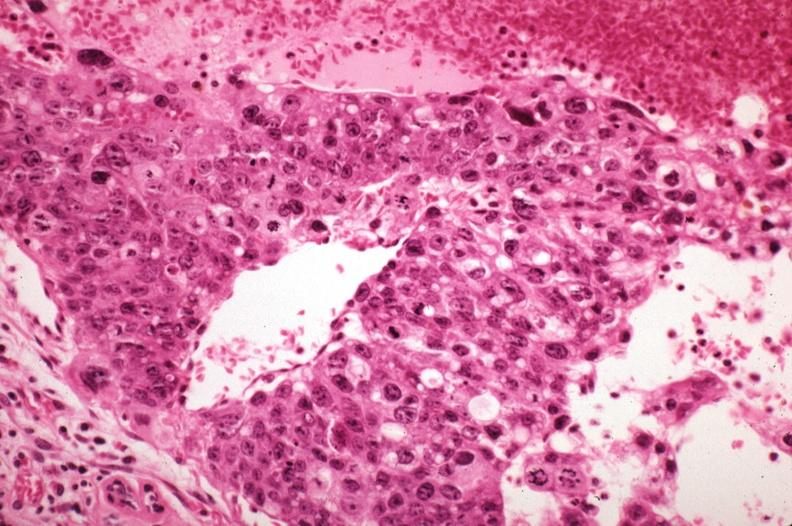s liver with tuberculoid granuloma in glissons sickled red cells in vessels well shown?
Answer the question using a single word or phrase. No 